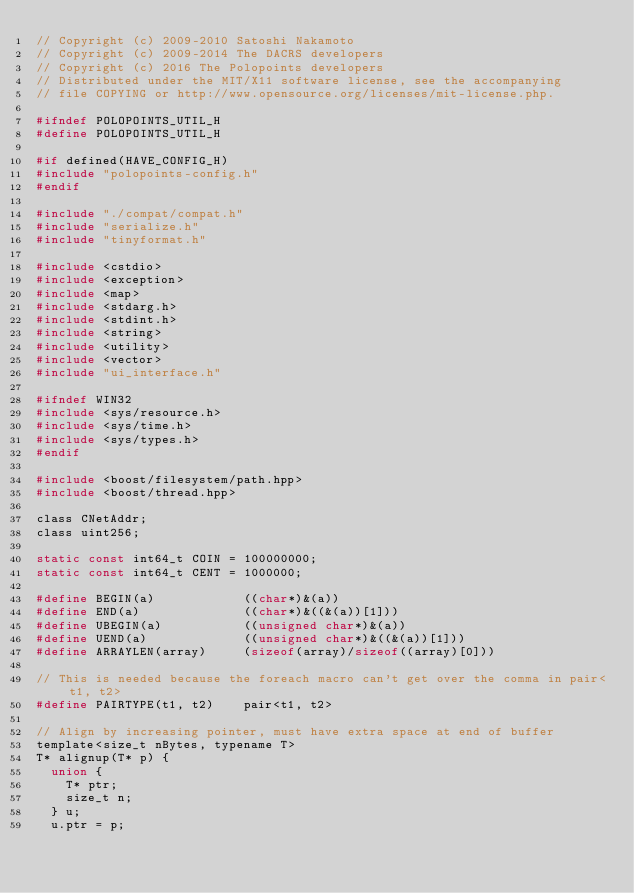<code> <loc_0><loc_0><loc_500><loc_500><_C_>// Copyright (c) 2009-2010 Satoshi Nakamoto
// Copyright (c) 2009-2014 The DACRS developers
// Copyright (c) 2016 The Polopoints developers
// Distributed under the MIT/X11 software license, see the accompanying
// file COPYING or http://www.opensource.org/licenses/mit-license.php.

#ifndef POLOPOINTS_UTIL_H
#define POLOPOINTS_UTIL_H

#if defined(HAVE_CONFIG_H)
#include "polopoints-config.h"
#endif

#include "./compat/compat.h"
#include "serialize.h"
#include "tinyformat.h"

#include <cstdio>
#include <exception>
#include <map>
#include <stdarg.h>
#include <stdint.h>
#include <string>
#include <utility>
#include <vector>
#include "ui_interface.h"

#ifndef WIN32
#include <sys/resource.h>
#include <sys/time.h>
#include <sys/types.h>
#endif

#include <boost/filesystem/path.hpp>
#include <boost/thread.hpp>

class CNetAddr;
class uint256;

static const int64_t COIN = 100000000;
static const int64_t CENT = 1000000;

#define BEGIN(a)            ((char*)&(a))
#define END(a)              ((char*)&((&(a))[1]))
#define UBEGIN(a)           ((unsigned char*)&(a))
#define UEND(a)             ((unsigned char*)&((&(a))[1]))
#define ARRAYLEN(array)     (sizeof(array)/sizeof((array)[0]))

// This is needed because the foreach macro can't get over the comma in pair<t1, t2>
#define PAIRTYPE(t1, t2)    pair<t1, t2>

// Align by increasing pointer, must have extra space at end of buffer
template<size_t nBytes, typename T>
T* alignup(T* p) {
	union {
		T* ptr;
		size_t n;
	} u;
	u.ptr = p;</code> 